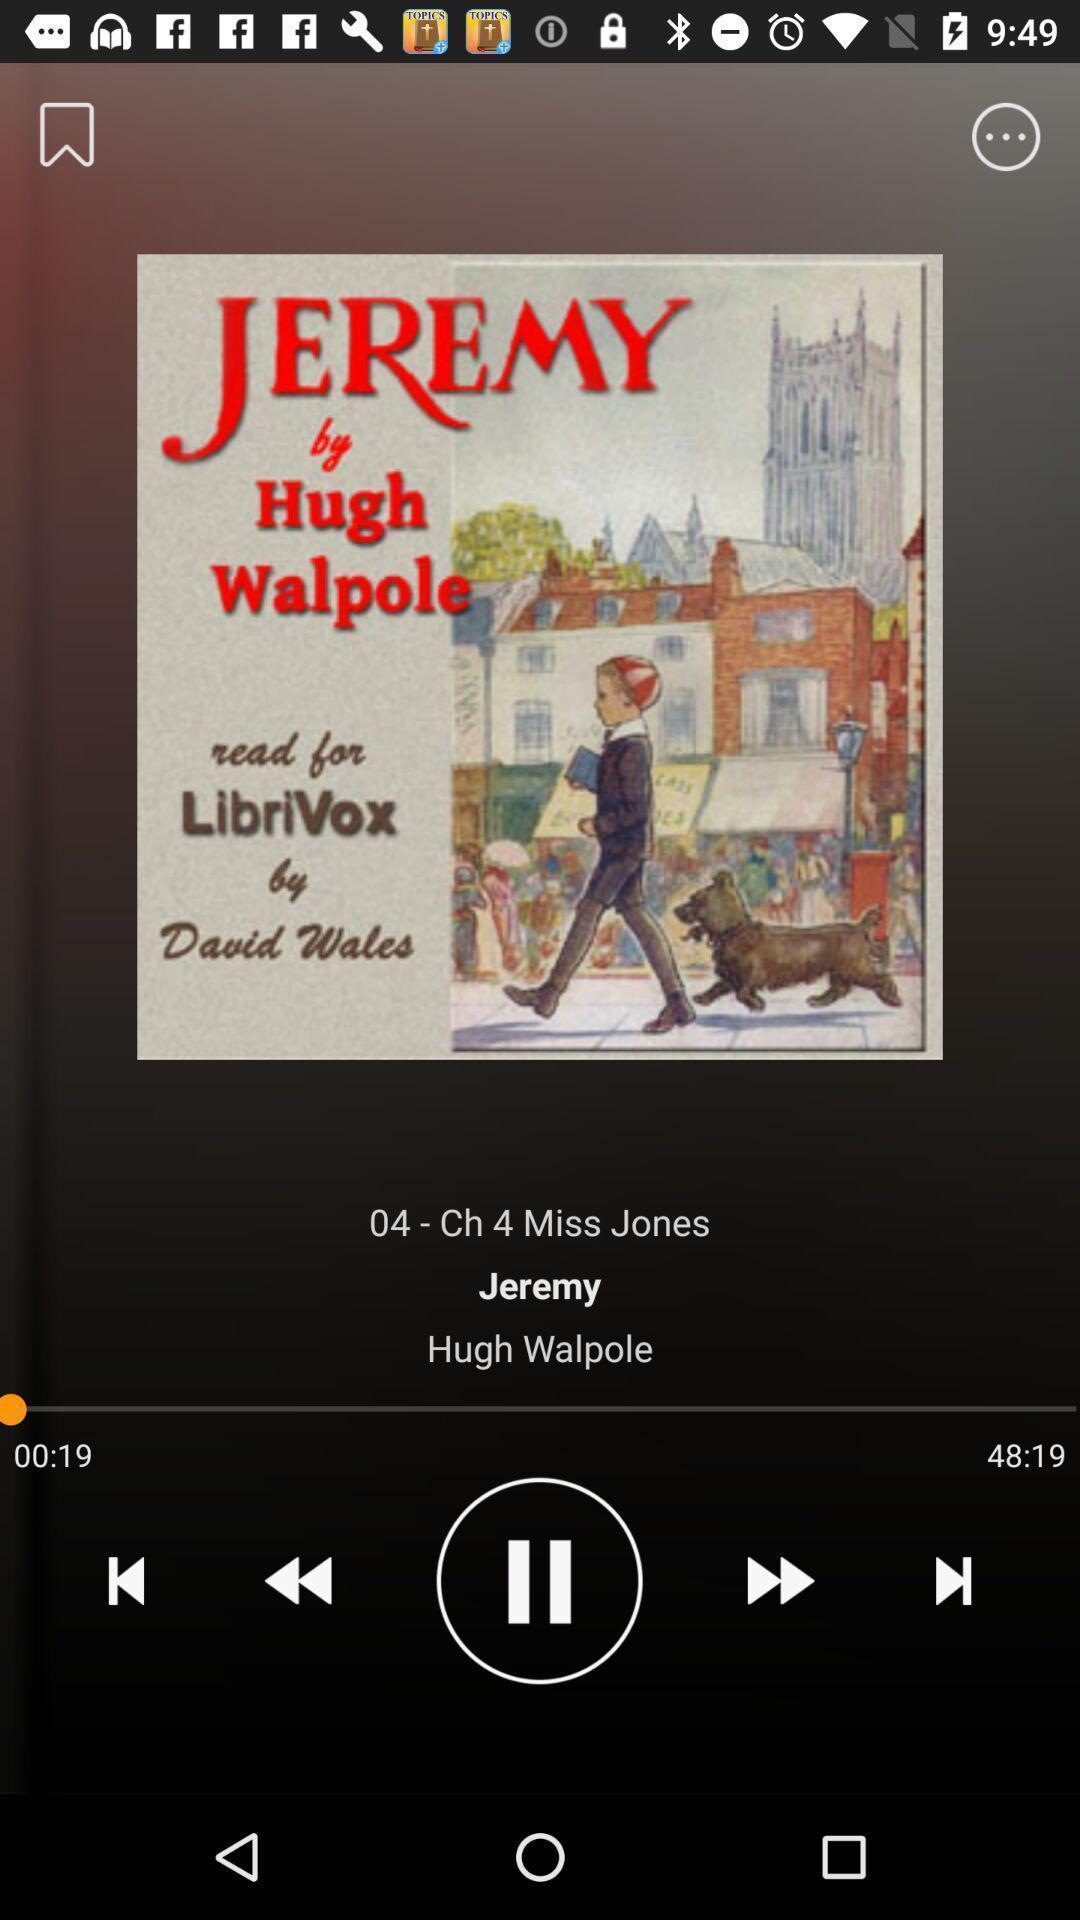Give me a summary of this screen capture. Song playing in the music app. 